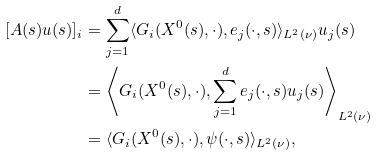<formula> <loc_0><loc_0><loc_500><loc_500>[ A ( s ) u ( s ) ] _ { i } & = \sum _ { j = 1 } ^ { d } \langle G _ { i } ( X ^ { 0 } ( s ) , \cdot ) , e _ { j } ( \cdot , s ) \rangle _ { L ^ { 2 } ( \nu ) } u _ { j } ( s ) \\ & = \left \langle G _ { i } ( X ^ { 0 } ( s ) , \cdot ) , \sum _ { j = 1 } ^ { d } e _ { j } ( \cdot , s ) u _ { j } ( s ) \right \rangle _ { L ^ { 2 } ( \nu ) } \\ & = \langle G _ { i } ( X ^ { 0 } ( s ) , \cdot ) , \psi ( \cdot , s ) \rangle _ { L ^ { 2 } ( \nu ) } ,</formula> 